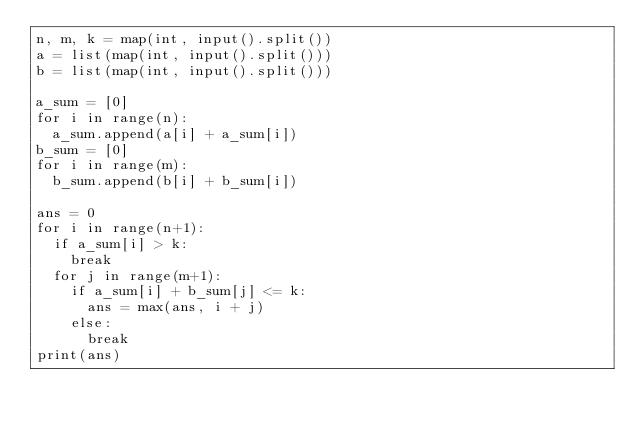Convert code to text. <code><loc_0><loc_0><loc_500><loc_500><_Python_>n, m, k = map(int, input().split())
a = list(map(int, input().split()))
b = list(map(int, input().split()))

a_sum = [0]
for i in range(n):
  a_sum.append(a[i] + a_sum[i])
b_sum = [0]
for i in range(m):
  b_sum.append(b[i] + b_sum[i])

ans = 0
for i in range(n+1):
  if a_sum[i] > k:
    break
  for j in range(m+1):
    if a_sum[i] + b_sum[j] <= k:
      ans = max(ans, i + j)
    else:
      break
print(ans)</code> 